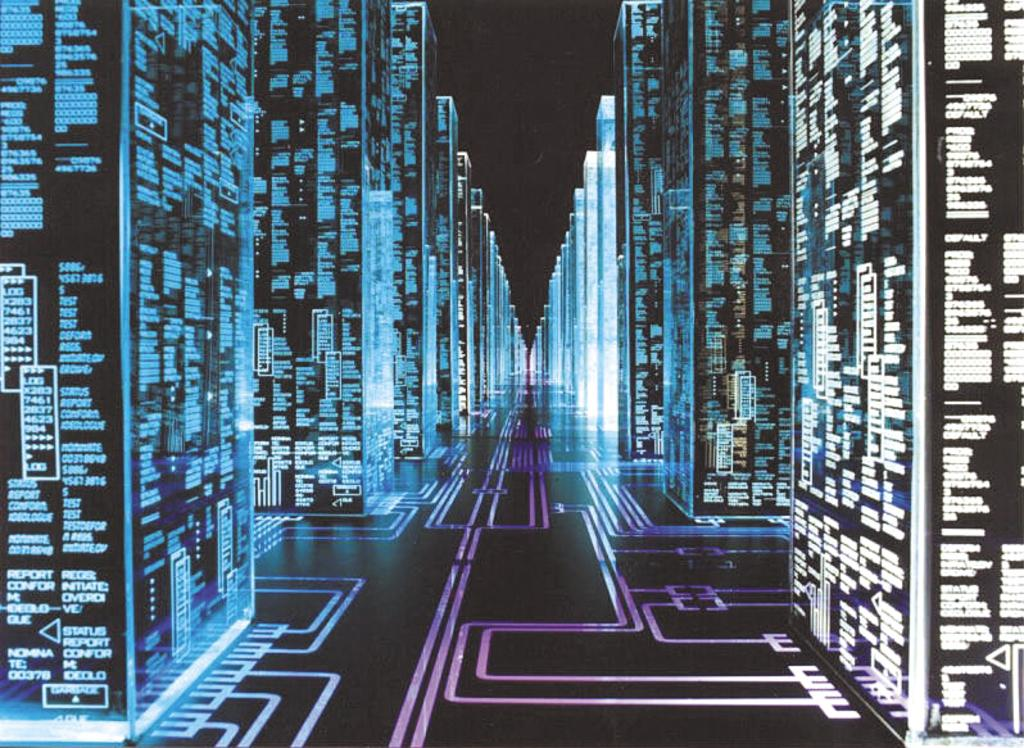What objects are present in the image? There are blocks in the image. What feature do the blocks have? The blocks have cords. How are the blocks related to each other in the image? There are connecting lines between the blocks. How many boats can be seen sailing in the background of the image? There are no boats visible in the image; it only features blocks with cords and connecting lines. 